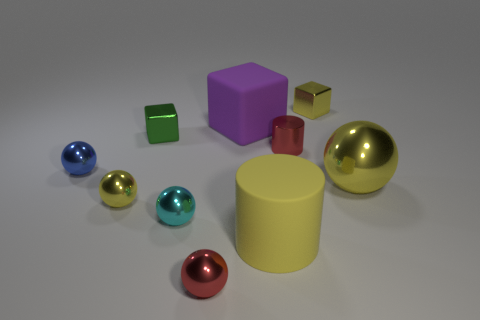Subtract all small cyan balls. How many balls are left? 4 Subtract 1 balls. How many balls are left? 4 Subtract all red spheres. How many spheres are left? 4 Subtract all purple balls. Subtract all blue cylinders. How many balls are left? 5 Subtract all cylinders. How many objects are left? 8 Subtract 0 cyan cylinders. How many objects are left? 10 Subtract all large blocks. Subtract all large yellow matte things. How many objects are left? 8 Add 3 red metal spheres. How many red metal spheres are left? 4 Add 8 big red metallic things. How many big red metallic things exist? 8 